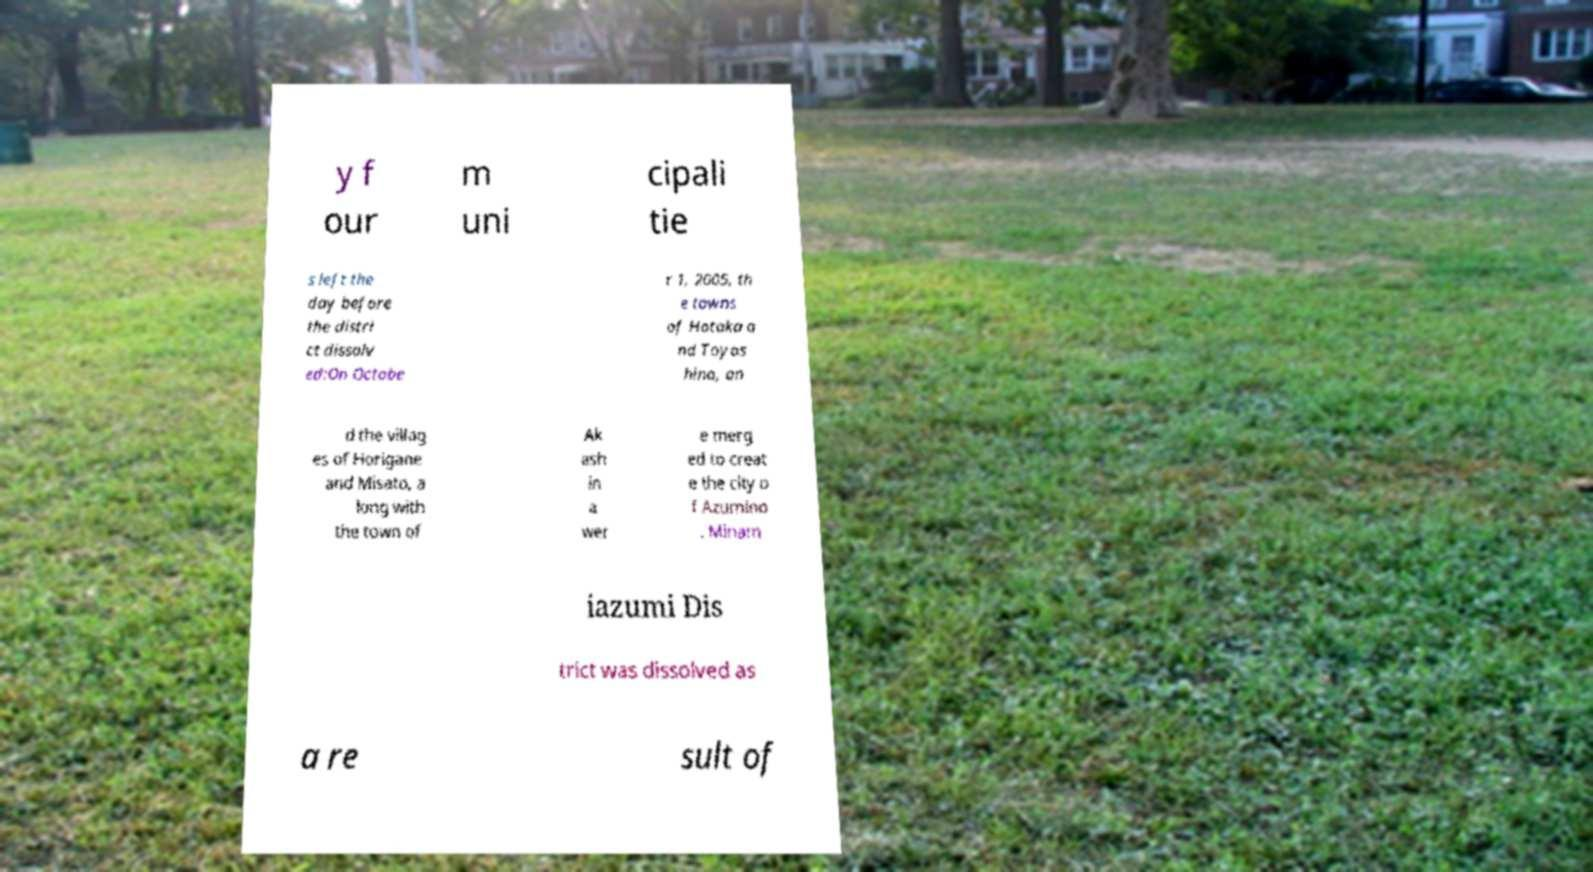I need the written content from this picture converted into text. Can you do that? y f our m uni cipali tie s left the day before the distri ct dissolv ed:On Octobe r 1, 2005, th e towns of Hotaka a nd Toyos hina, an d the villag es of Horigane and Misato, a long with the town of Ak ash in a wer e merg ed to creat e the city o f Azumino . Minam iazumi Dis trict was dissolved as a re sult of 